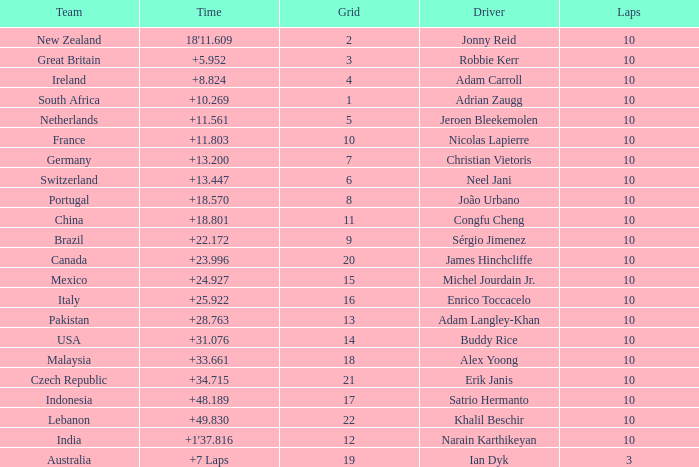What is the Grid number for the Team from Italy? 1.0. 